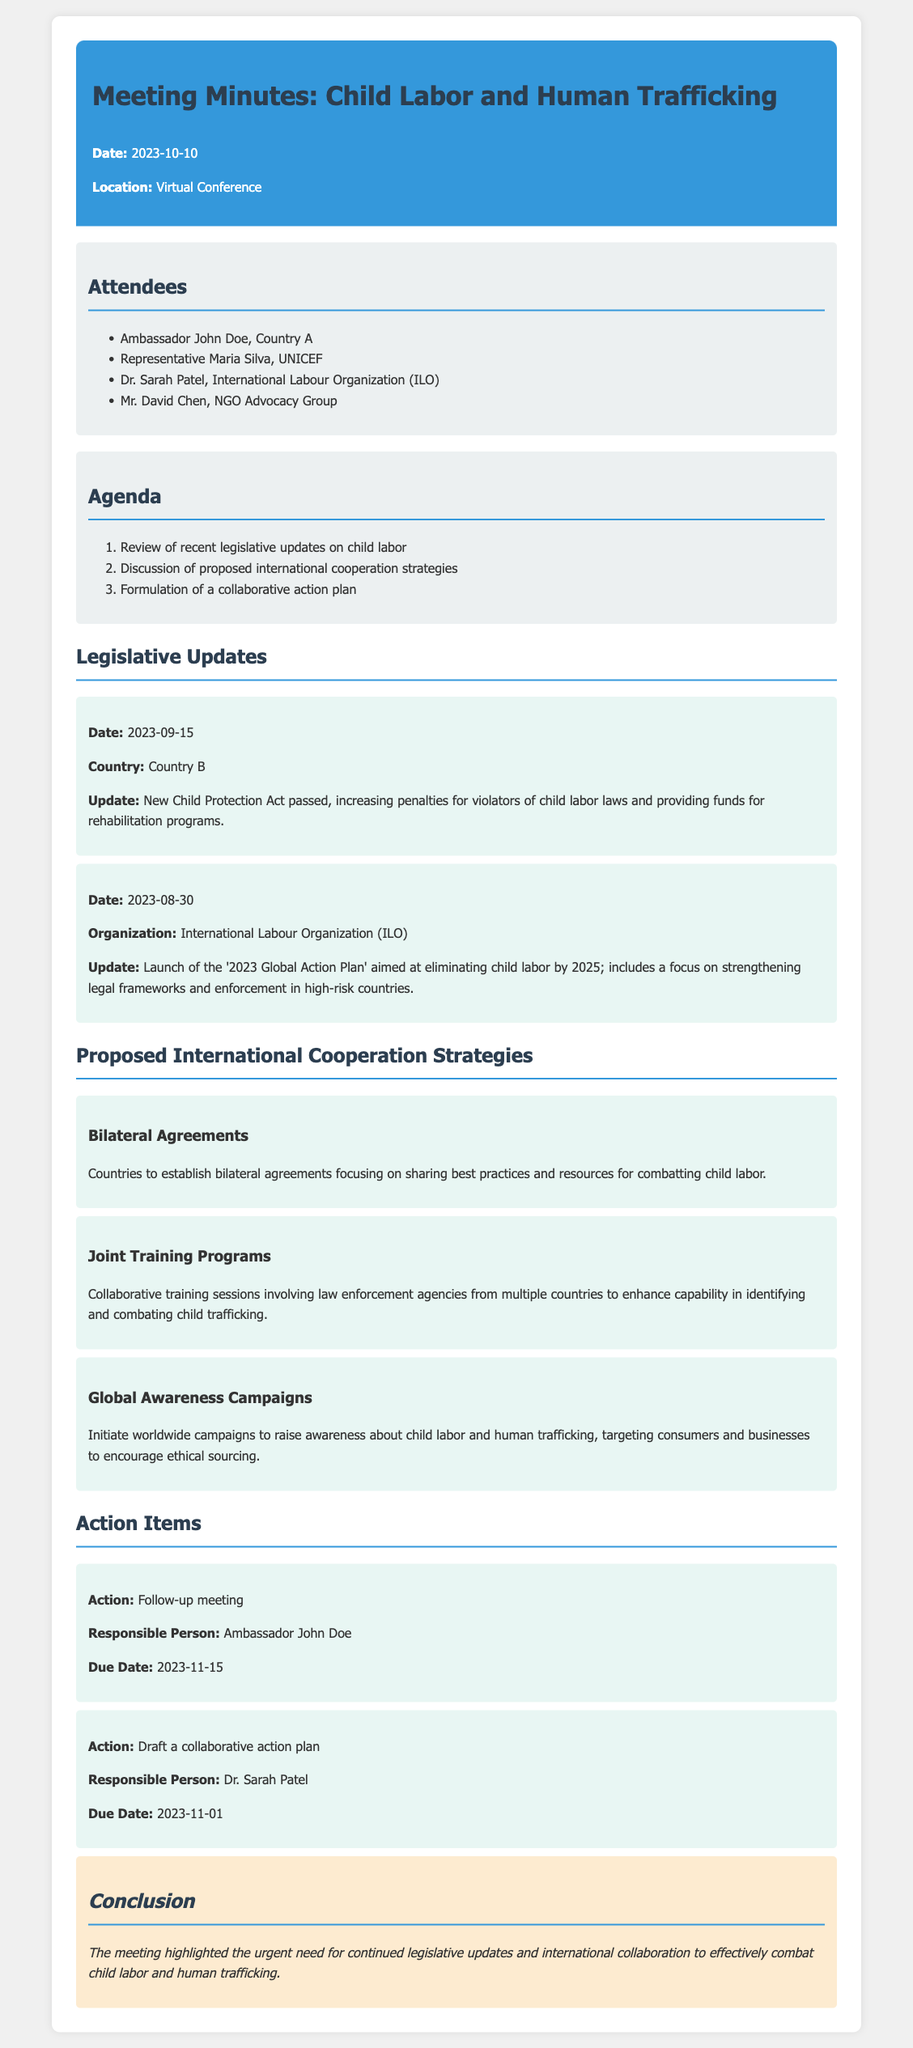What is the date of the meeting? The date of the meeting is stated at the beginning of the document.
Answer: 2023-10-10 Who is the representative from UNICEF? The attendees section lists the representatives present at the meeting.
Answer: Representative Maria Silva What was the new legislation passed in Country B? The legislative updates section provides specific details about recent legislative actions.
Answer: New Child Protection Act What is the focus of the '2023 Global Action Plan'? The updates section describes the aim of the Global Action Plan initiated by the ILO.
Answer: Eliminating child labor by 2025 Who is responsible for drafting the collaborative action plan? The action items list identifies who is responsible for each action item discussed in the meeting.
Answer: Dr. Sarah Patel How many strategies for international cooperation are proposed? The proposed international cooperation strategies section lists multiple strategies discussed in the meeting.
Answer: Three What is the due date for the follow-up meeting? The action items section includes specific due dates for the actions discussed.
Answer: 2023-11-15 What is the overall conclusion of the meeting? The conclusion section summarizes the key takeaways from the meeting.
Answer: Urgent need for continued legislative updates and international collaboration 